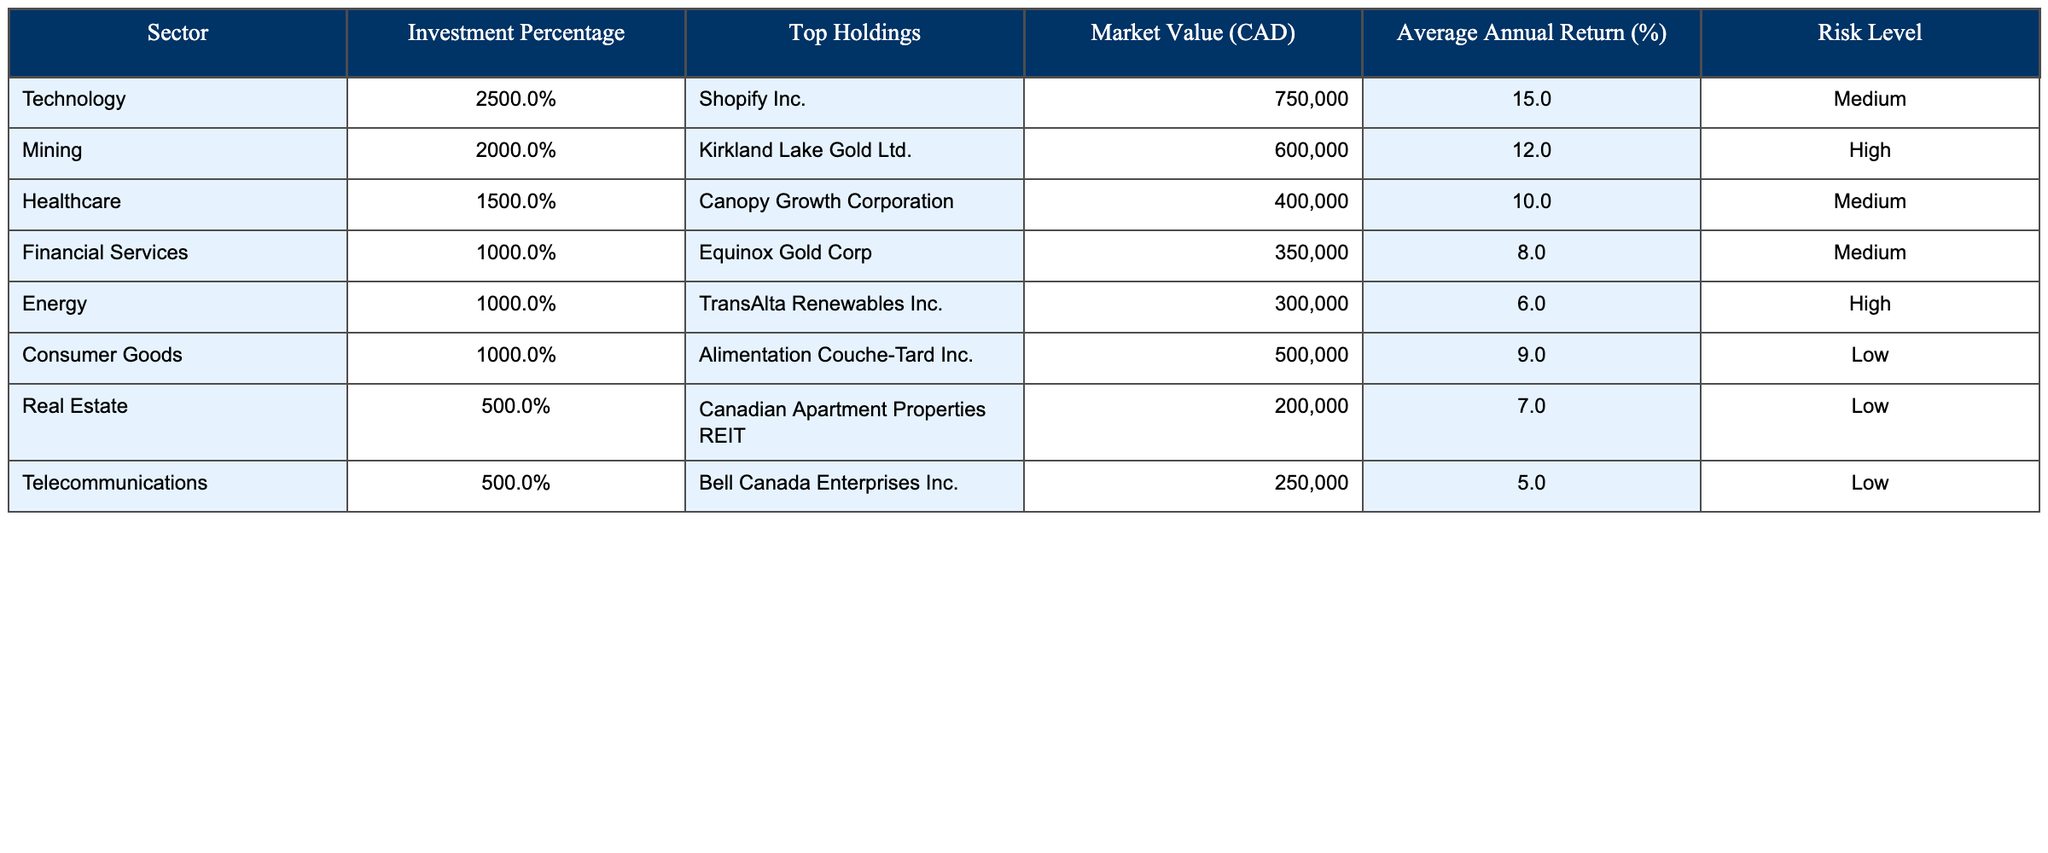What is the sector with the highest investment percentage? By examining the "Investment Percentage" column in the table, Technology has the highest value at 25%.
Answer: Technology What is the market value of the top holding in the Mining sector? The table shows that the top holding in the Mining sector is Kirkland Lake Gold Ltd. with a Market Value of CAD 600,000.
Answer: CAD 600,000 What is the average annual return for the Healthcare sector? The table indicates that the average annual return for the Healthcare sector, represented by Canopy Growth Corporation, is 10%.
Answer: 10% Which sector has the lowest risk level? By reviewing the "Risk Level" column, Consumer Goods, Real Estate, and Telecommunications all have a risk level of Low, which is the lowest category.
Answer: Consumer Goods, Real Estate, Telecommunications What is the total investment percentage of the sectors with a high-risk level? The sectors with a high-risk level are Mining and Energy, with percentages of 20% and 10% respectively. Summing these gives 20% + 10% = 30%.
Answer: 30% Is the average annual return for Financial Services greater than 9%? The Financial Services sector shows an average annual return of 8%, which is less than 9%.
Answer: No What is the combined market value of sectors with a medium risk level? The sectors with a medium risk level are Technology, Healthcare, and Financial Services, with market values of CAD 750,000, CAD 400,000, and CAD 350,000 respectively. The total market value is CAD 750,000 + CAD 400,000 + CAD 350,000 = CAD 1,500,000.
Answer: CAD 1,500,000 Which sector has the highest average annual return and what is that return? Reviewing the average annual return for each sector, Technology has the highest return at 15%.
Answer: 15% How many sectors have a market value greater than CAD 400,000? The sectors with a market value greater than CAD 400,000 are Technology (CAD 750,000), Mining (CAD 600,000), and Consumer Goods (CAD 500,000). This counts to 3 sectors.
Answer: 3 What is the risk level of the top holding in the Energy sector? The top holding in the Energy sector is TransAlta Renewables Inc., which has a risk level of High, as indicated in the table.
Answer: High 